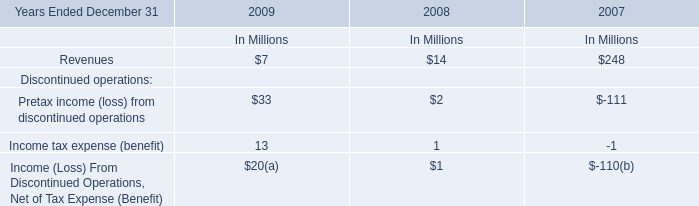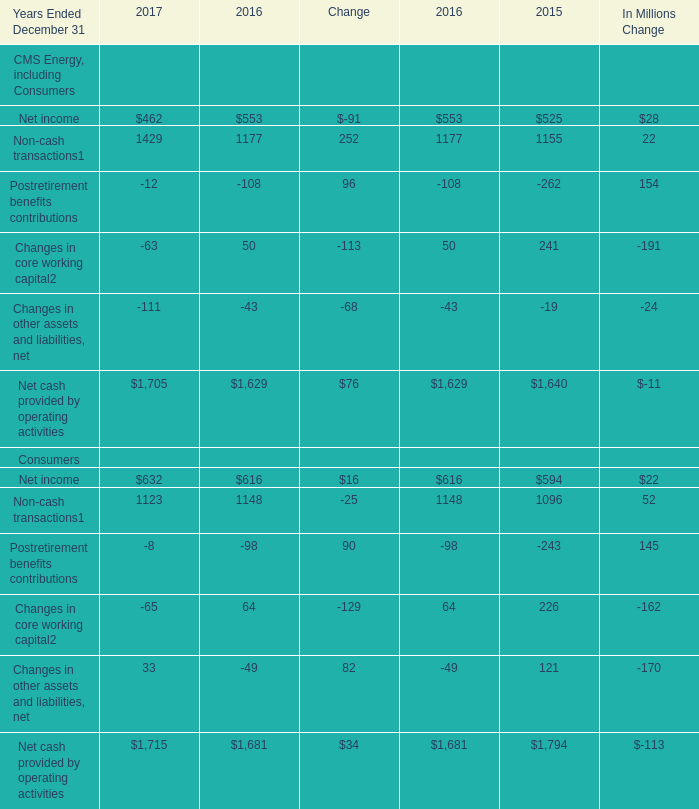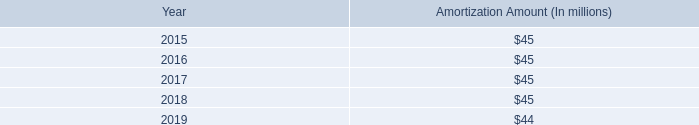What was the total amount of CMS Energy, including Consumers in 2017? (in million) 
Computations: (((((462 + 1429) + -12) + -63) + -111) + 1705)
Answer: 3410.0. 